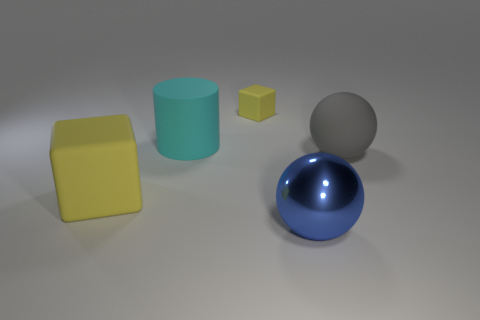Is the color of the tiny rubber block the same as the ball on the right side of the large shiny sphere? no 